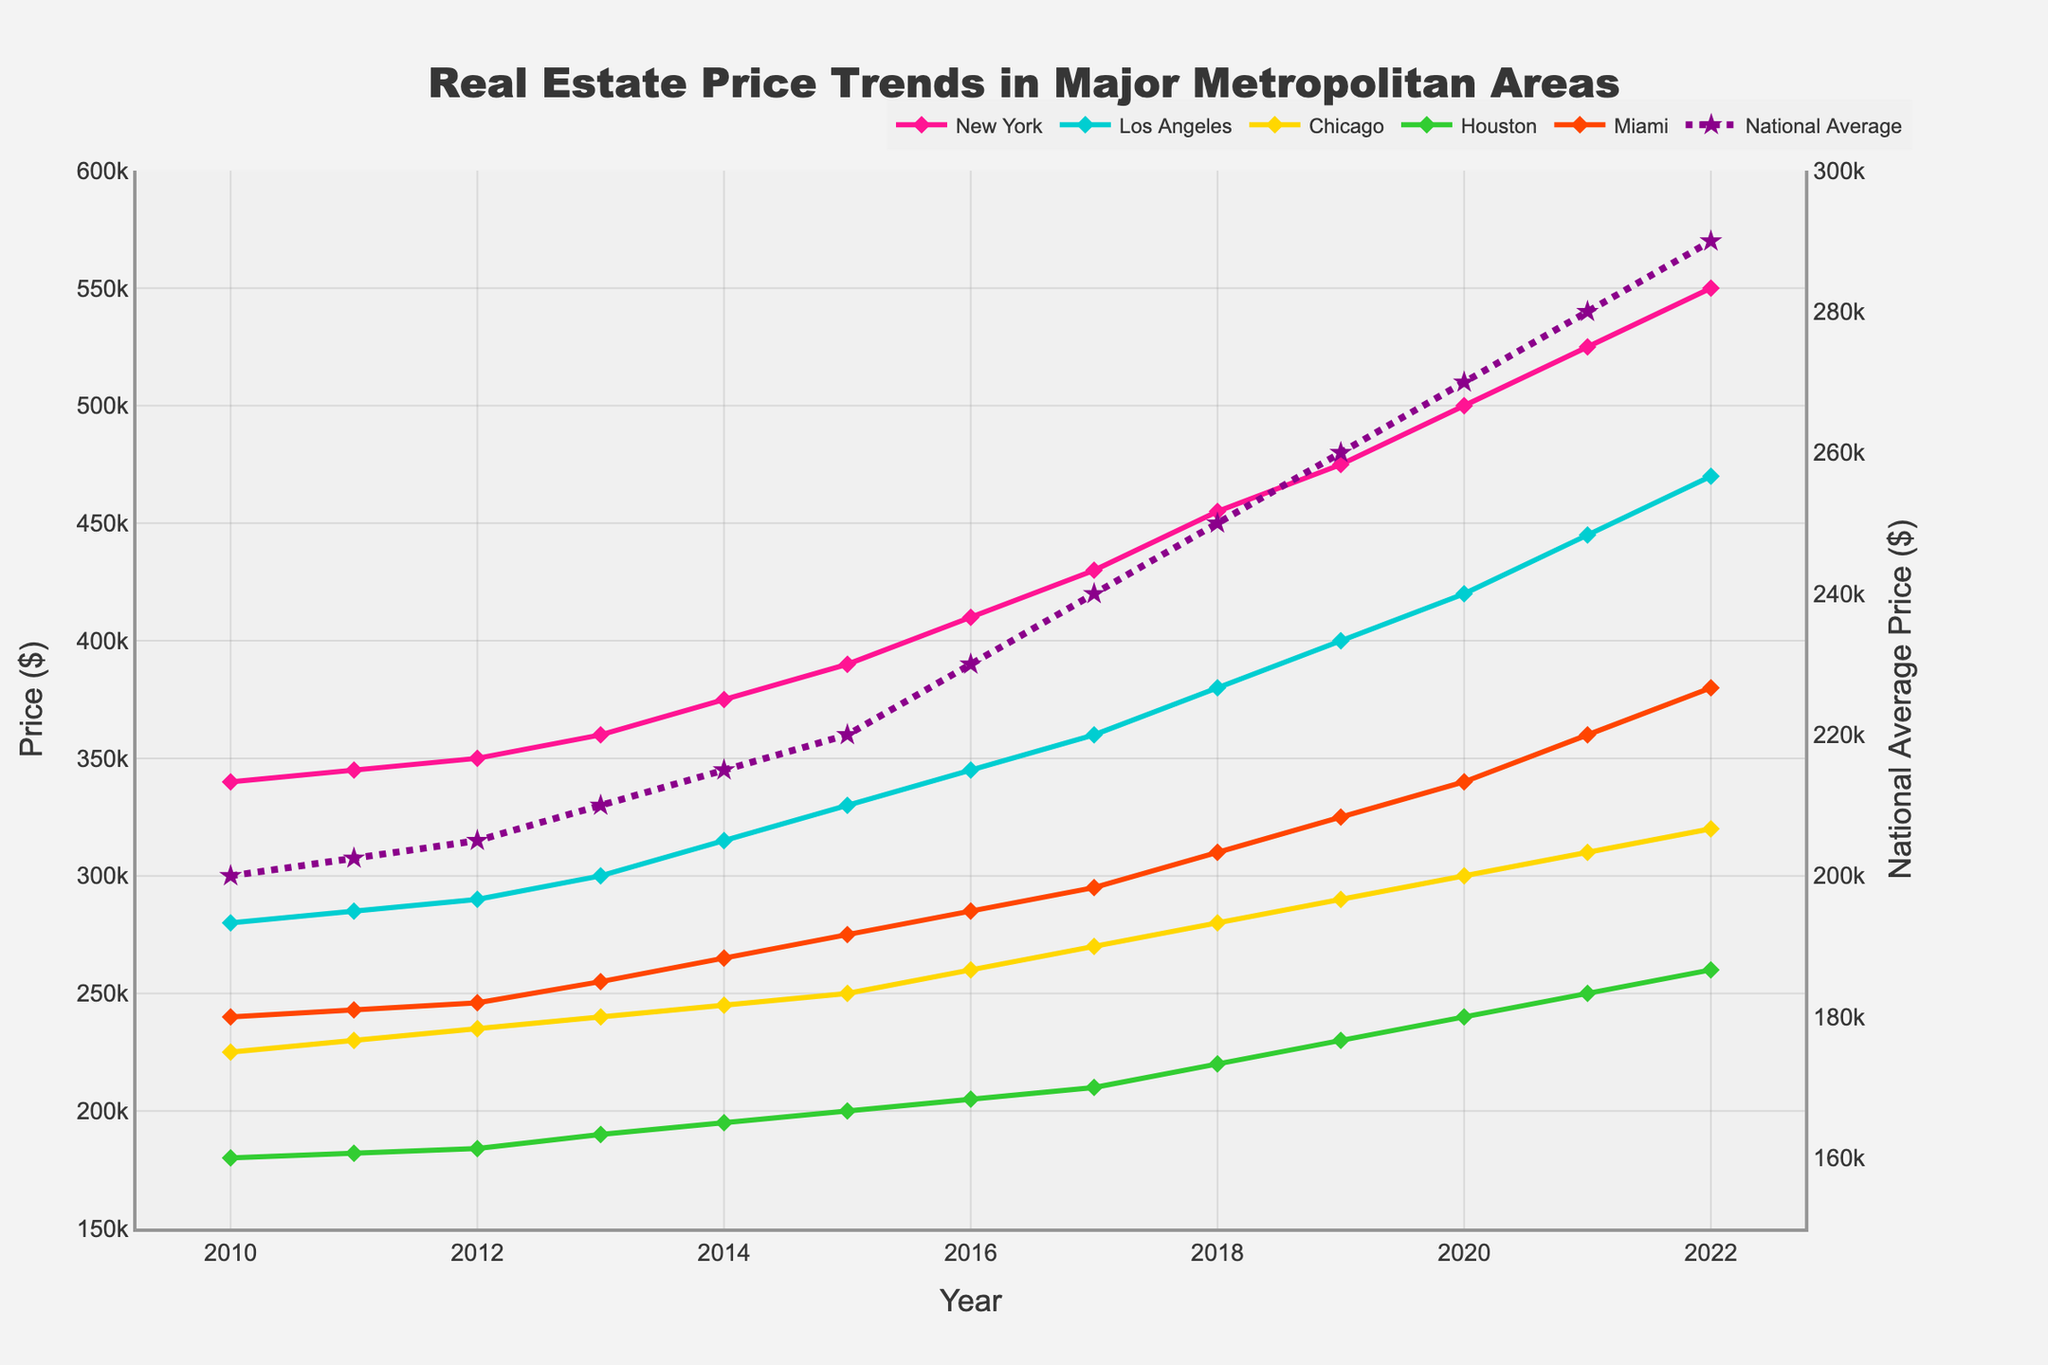What is the trend of real estate prices in New York from 2010 to 2022? By looking at the line representing New York, it can be seen that prices increase steadily from 2010 to 2022. The price starts at $340,000 in 2010 and reaches $550,000 in 2022.
Answer: Prices steadily increase What is the difference between the 2022 prices in New York and Chicago? The price for New York in 2022 is $550,000, and the price for Chicago in 2022 is $320,000. The difference is $550,000 - $320,000.
Answer: $230,000 Which city shows the highest increase in real estate prices from 2010 to 2022? By comparing the starting and ending prices for each city, New York stands out with an increase from $340,000 in 2010 to $550,000 in 2022, which is a rise of $210,000. Other cities have smaller increases.
Answer: New York How do real estate prices in Miami in 2020 compare to the National Average in the same year? The price in Miami in 2020 is $340,000, while the National Average is $270,000. Miami's price is higher.
Answer: Miami's price is higher Which city had the lowest real estate price in 2010, and what is the amount? By examining the starting points of the lines in 2010, Houston has the lowest price at $180,000.
Answer: Houston at $180,000 What is the percentage increase in real estate prices for Los Angeles from 2015 to 2022? The price in Los Angeles in 2015 is $330,000 and in 2022 is $470,000. The increase is $470,000 - $330,000 = $140,000. The percentage increase is ($140,000 / $330,000) * 100.
Answer: 42.42% In which year do Chicago's real estate prices reach $300,000? By following the line representing Chicago, the price reaches $300,000 in the year 2022.
Answer: 2022 How do the 2022 National Average prices compare to the average of all city prices in the same year? In 2022, adding up all city prices: New York $550,000, Los Angeles $470,000, Chicago $320,000, Houston $260,000, Miami $380,000. The sum is $550,000 + $470,000 + $320,000 + $260,000 + $380,000 = $1,980,000. Dividing by 5 (number of cities), the average is $1,980,000 / 5 = $396,000. The National Average is $290,000, less than the cities' average.
Answer: Cities' average is higher What pattern do you notice in the relationship between Miami's real estate prices and the National Average from 2010 to 2022? Throughout the years, Miami's prices are consistently higher than the National Average, and the gap between them increases as both trends ascend.
Answer: Miami's prices are consistently higher 